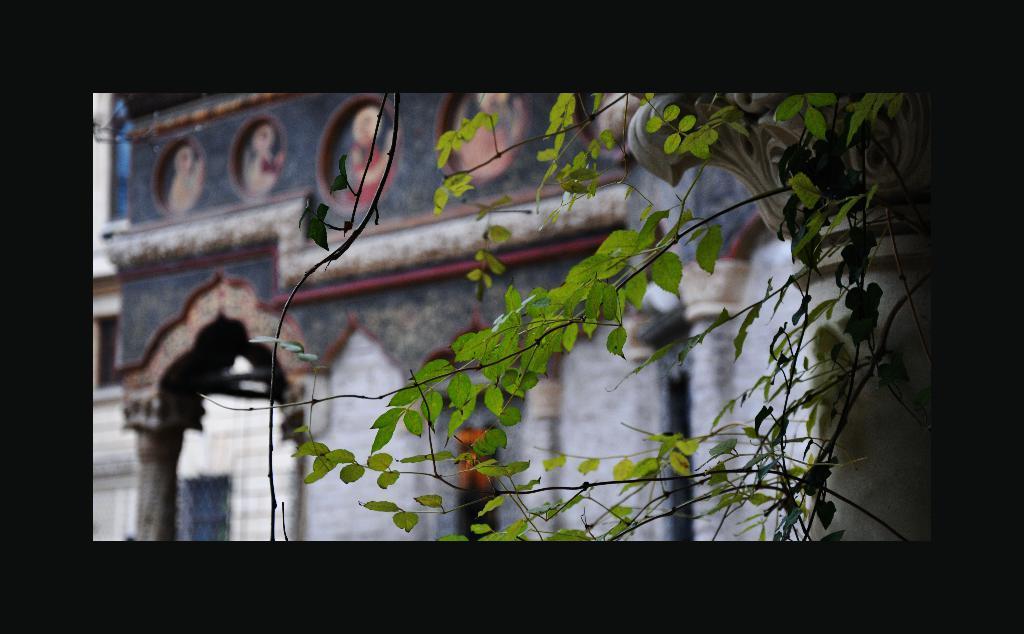Please provide a concise description of this image. At the right corner of the image there are stems of the tree with leaves. Behind the stems there is a pillar with design on it. In the background there is a building with wall, pillars and also there is an arch. 